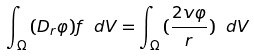Convert formula to latex. <formula><loc_0><loc_0><loc_500><loc_500>\int _ { \Omega } { ( D _ { r } \varphi ) f \ d V = \int _ { \Omega } { ( \frac { 2 v \varphi } { r } } ) } \ d V</formula> 